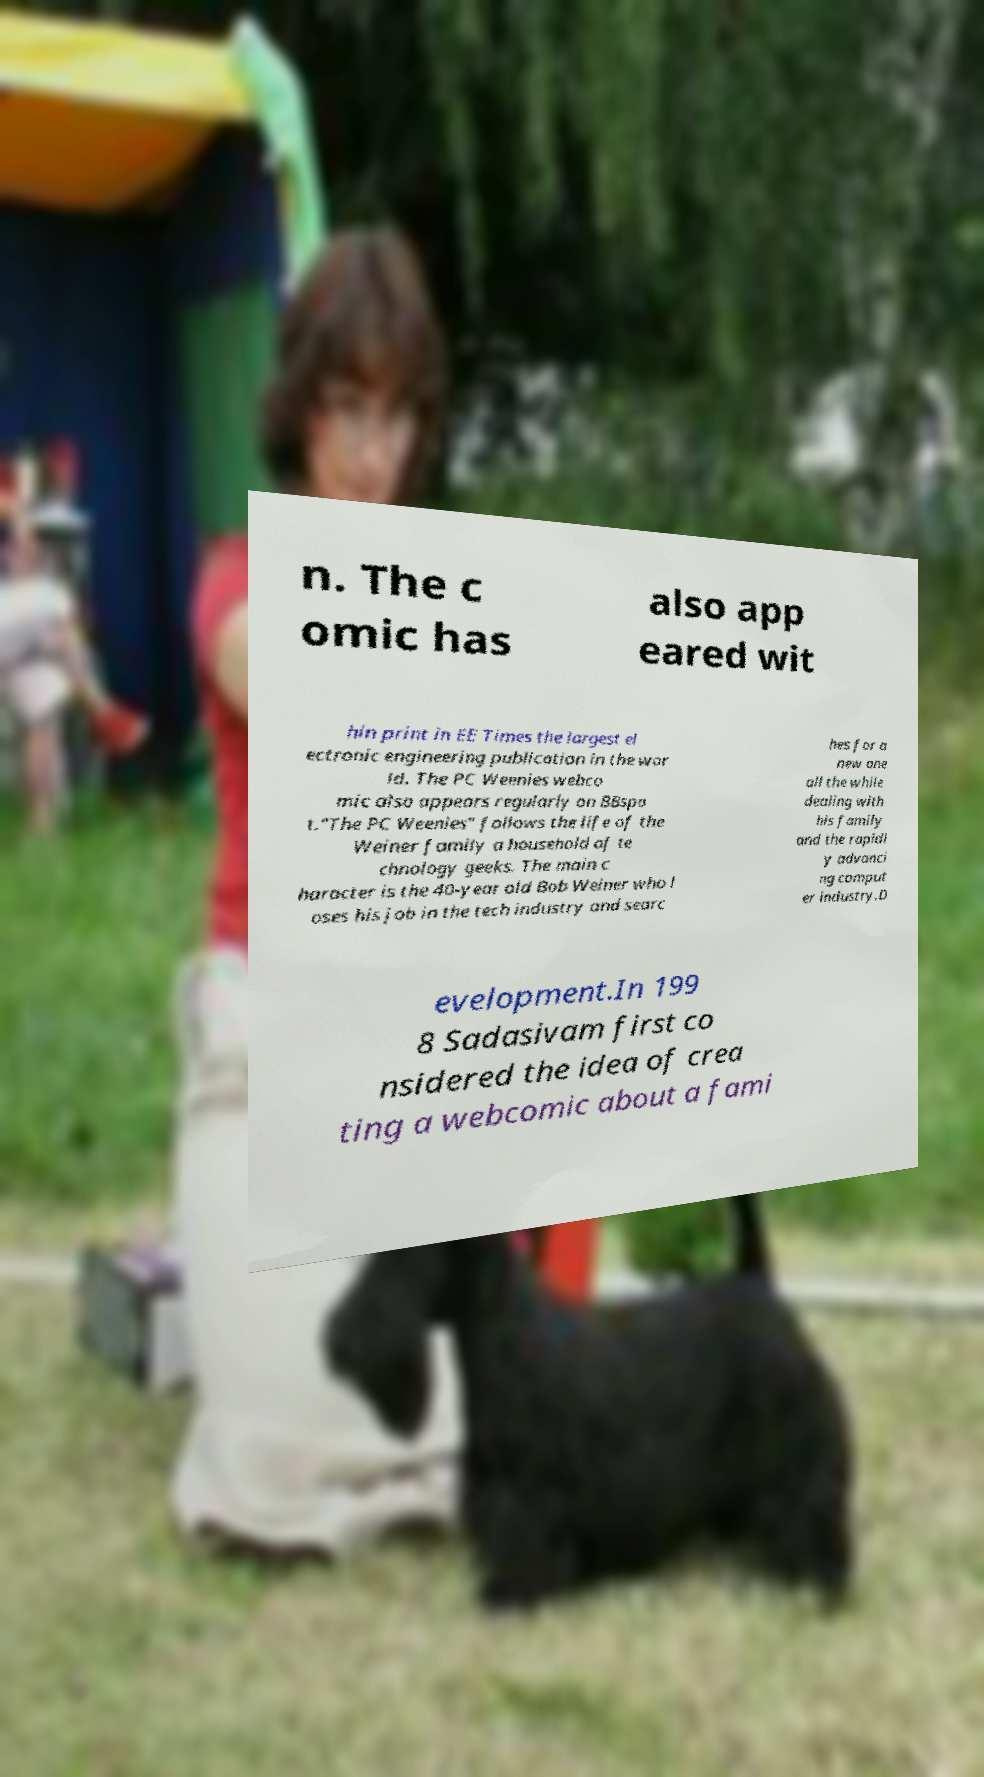I need the written content from this picture converted into text. Can you do that? n. The c omic has also app eared wit hin print in EE Times the largest el ectronic engineering publication in the wor ld. The PC Weenies webco mic also appears regularly on BBspo t."The PC Weenies" follows the life of the Weiner family a household of te chnology geeks. The main c haracter is the 40-year old Bob Weiner who l oses his job in the tech industry and searc hes for a new one all the while dealing with his family and the rapidl y advanci ng comput er industry.D evelopment.In 199 8 Sadasivam first co nsidered the idea of crea ting a webcomic about a fami 